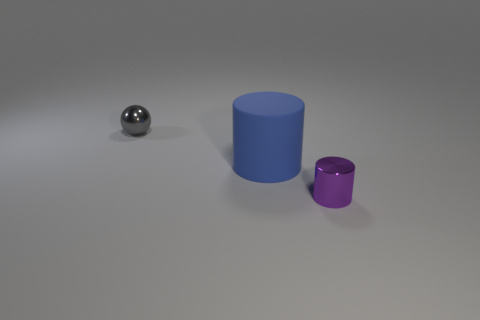Are there any other things that have the same size as the blue rubber cylinder?
Your answer should be very brief. No. What number of objects are either rubber things or small things that are to the right of the blue object?
Provide a succinct answer. 2. There is a gray object that is the same material as the purple thing; what size is it?
Keep it short and to the point. Small. What is the shape of the shiny object to the left of the metal object to the right of the sphere?
Provide a short and direct response. Sphere. What size is the thing that is on the left side of the small cylinder and right of the gray ball?
Offer a very short reply. Large. Is there a blue object of the same shape as the tiny gray object?
Ensure brevity in your answer.  No. Is there anything else that has the same shape as the gray metallic object?
Give a very brief answer. No. The small object that is behind the small shiny object that is in front of the small metal object to the left of the purple thing is made of what material?
Ensure brevity in your answer.  Metal. Are there any shiny cylinders of the same size as the blue rubber cylinder?
Your answer should be compact. No. There is a metal object that is behind the shiny object in front of the tiny gray shiny sphere; what color is it?
Provide a succinct answer. Gray. 